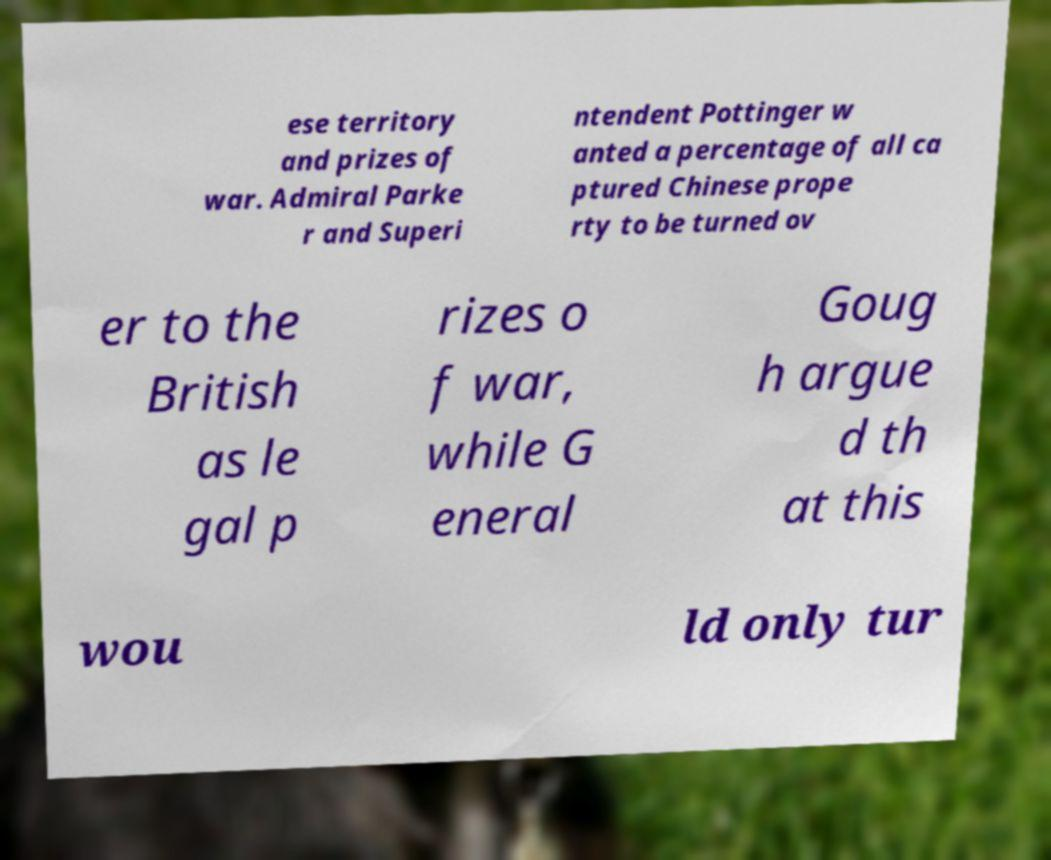Can you read and provide the text displayed in the image?This photo seems to have some interesting text. Can you extract and type it out for me? ese territory and prizes of war. Admiral Parke r and Superi ntendent Pottinger w anted a percentage of all ca ptured Chinese prope rty to be turned ov er to the British as le gal p rizes o f war, while G eneral Goug h argue d th at this wou ld only tur 